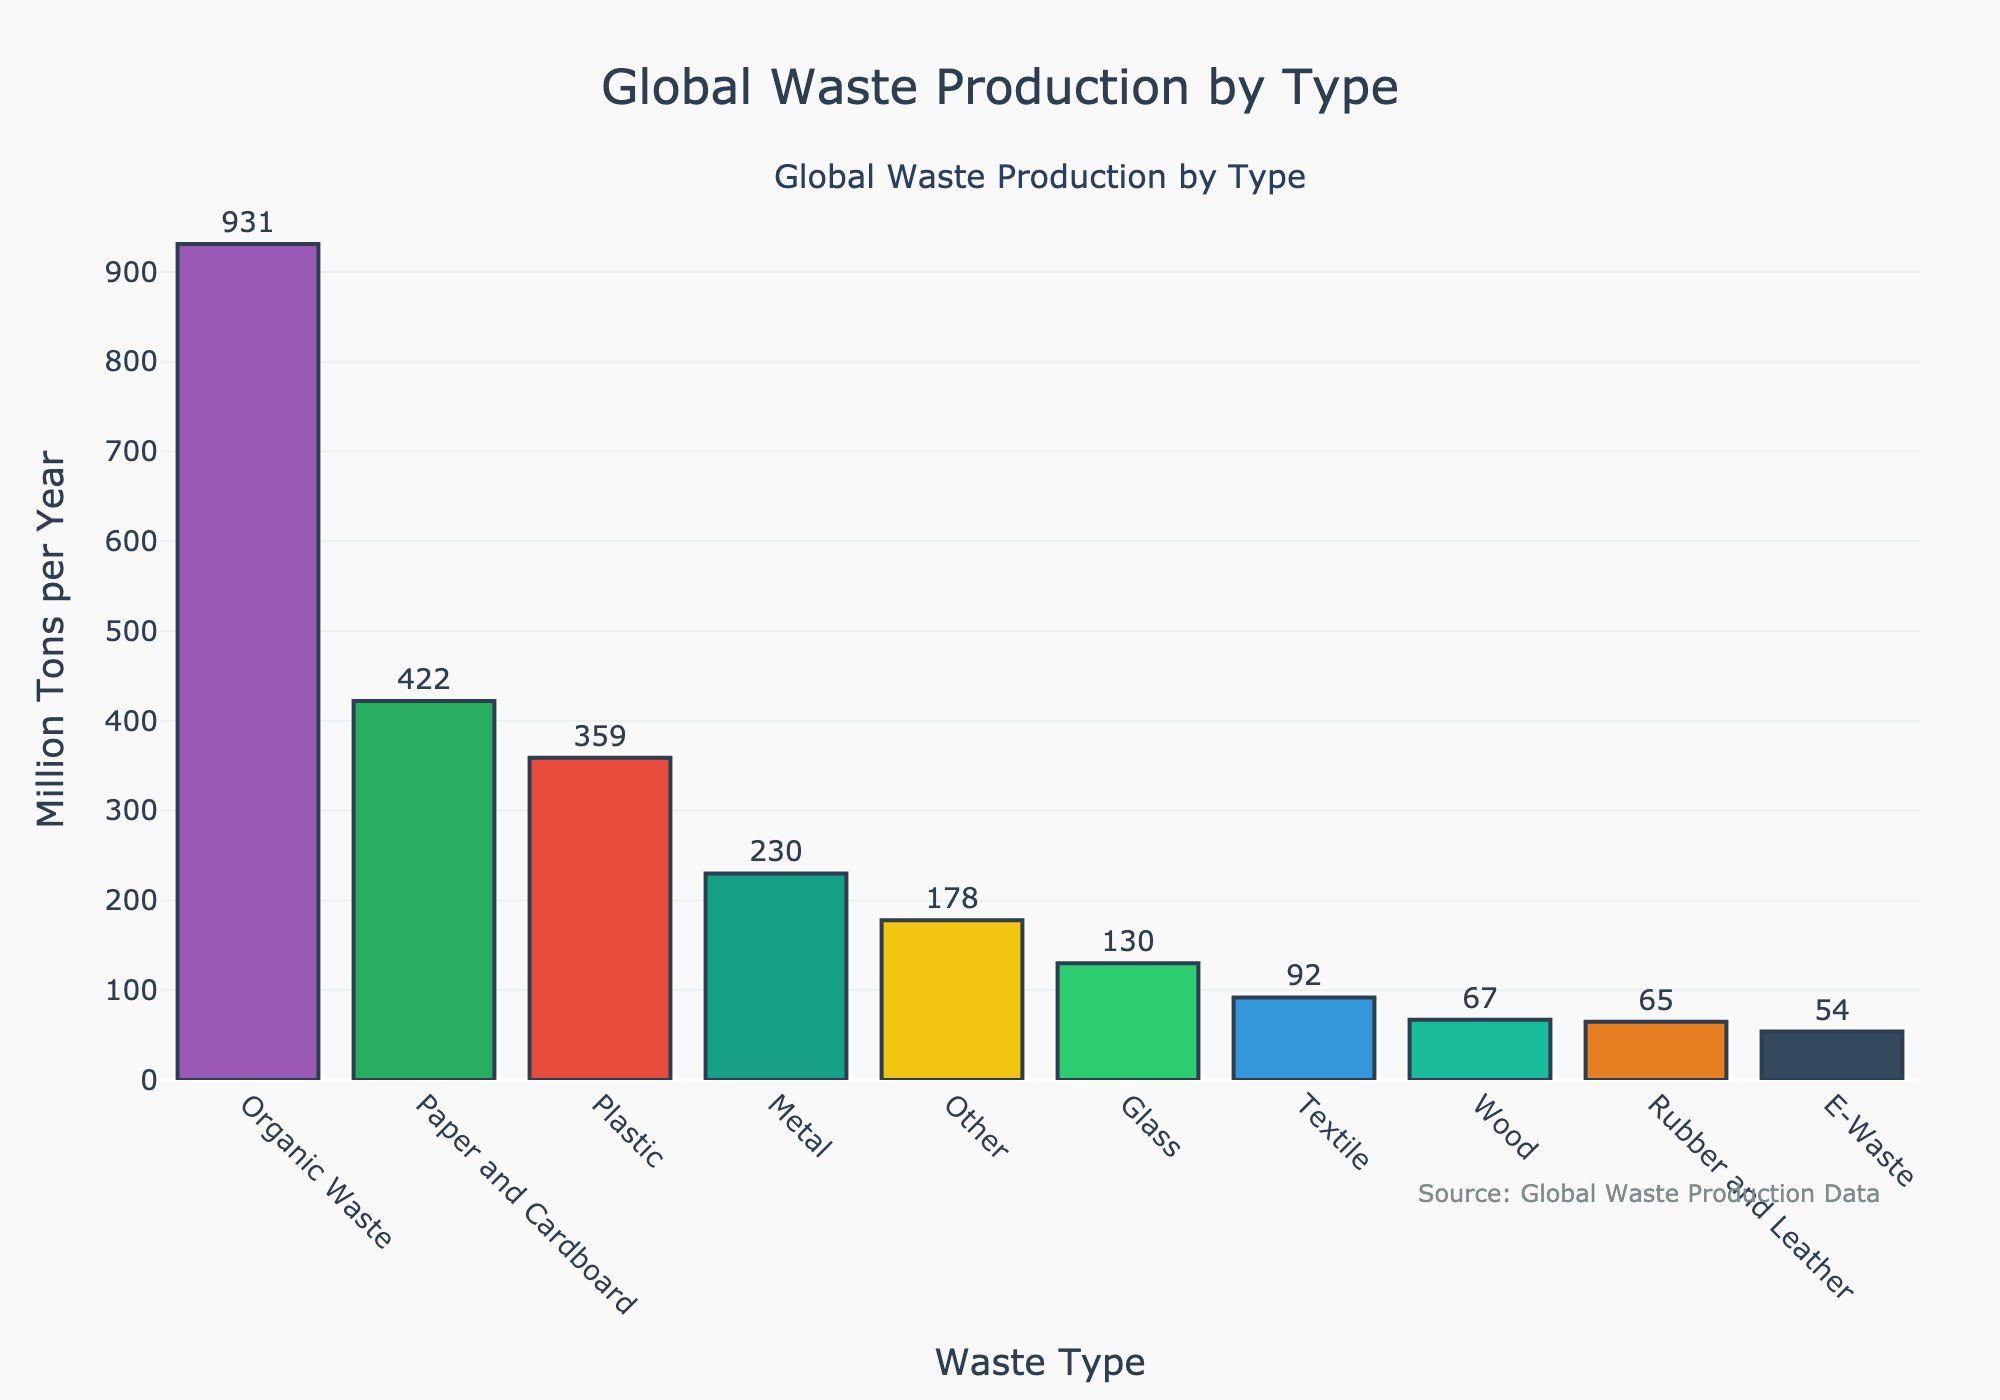What type of waste has the highest global production per year? Identify the bar with the highest value on the y-axis. The tallest bar represents "Organic Waste" at 931 million tons per year.
Answer: Organic Waste What is the total global production per year of Plastic and Paper and Cardboard waste combined? Locate the bars for Plastic and Paper and Cardboard, then sum their values: 359 (Plastic) + 422 (Paper and Cardboard) = 781 million tons per year.
Answer: 781 million tons per year Which type of waste has a lower production per year: E-Waste or Rubber and Leather? Compare the heights of the bars for E-Waste (54 million tons) and Rubber and Leather (65 million tons). E-Waste is lower.
Answer: E-Waste How much more Organic Waste is produced than Glass waste per year? Subtract the value for Glass (130 million tons) from the value for Organic Waste (931 million tons): 931 - 130 = 801 million tons.
Answer: 801 million tons What is the average global production per year for Metal, Glass, and Wood waste types? Find the values: Metal (230 million tons), Glass (130 million tons), Wood (67 million tons). Sum them and divide by 3 to find the average: (230 + 130 + 67) / 3 = 142.33 million tons per year.
Answer: 142.33 million tons per year Which waste type is represented by a green-colored bar? Identify the green-colored bar representation. Since visual identification is subjective and color varies by random assignment in this scenario, this answer cannot be conclusively determined without seeing the plot.
Answer: Varies What's the combined total of E-Waste, Textile, and Rubber and Leather waste? Sum the respective values: E-Waste (54 million tons), Textile (92 million tons), Rubber and Leather (65 million tons): 54 + 92 + 65 = 211 million tons per year.
Answer: 211 million tons per year Among Organic Waste, Plastic, and Paper and Cardboard, which type is closest to producing 400 million tons per year? Check the values: Organic Waste (931 million tons), Plastic (359 million tons), Paper and Cardboard (422 million tons). Paper and Cardboard is closest to 400 million tons.
Answer: Paper and Cardboard How much more waste is produced from Organic Waste compared to the total of Textile, E-Waste, and Wood? Sum Textile (92 million tons), E-Waste (54 million tons), and Wood (67 million tons): 92 + 54 + 67 = 213. Then subtract 213 from Organic Waste (931 million tons): 931 - 213 = 718 million tons.
Answer: 718 million tons Is the production of Metal waste greater than the sum of Wood and Textile waste? Sum Wood (67 million tons) and Textile (92 million tons): 67 + 92 = 159. Compare this with Metal (230 million tons). Since 230 > 159, Metal waste is greater.
Answer: Yes 